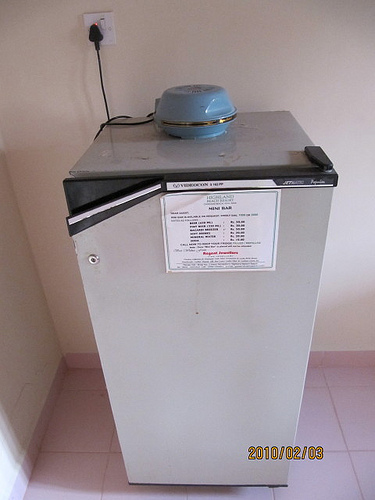<image>What is on top of the fridge? I don't know what is on top of the fridge. It can be an appliance, a bowl, or some kind of container. What is on top of the fridge? I am not sure what is on top of the fridge. It can be seen as an appliance, small appliance, electric device, toaster, bowl, or a container. 